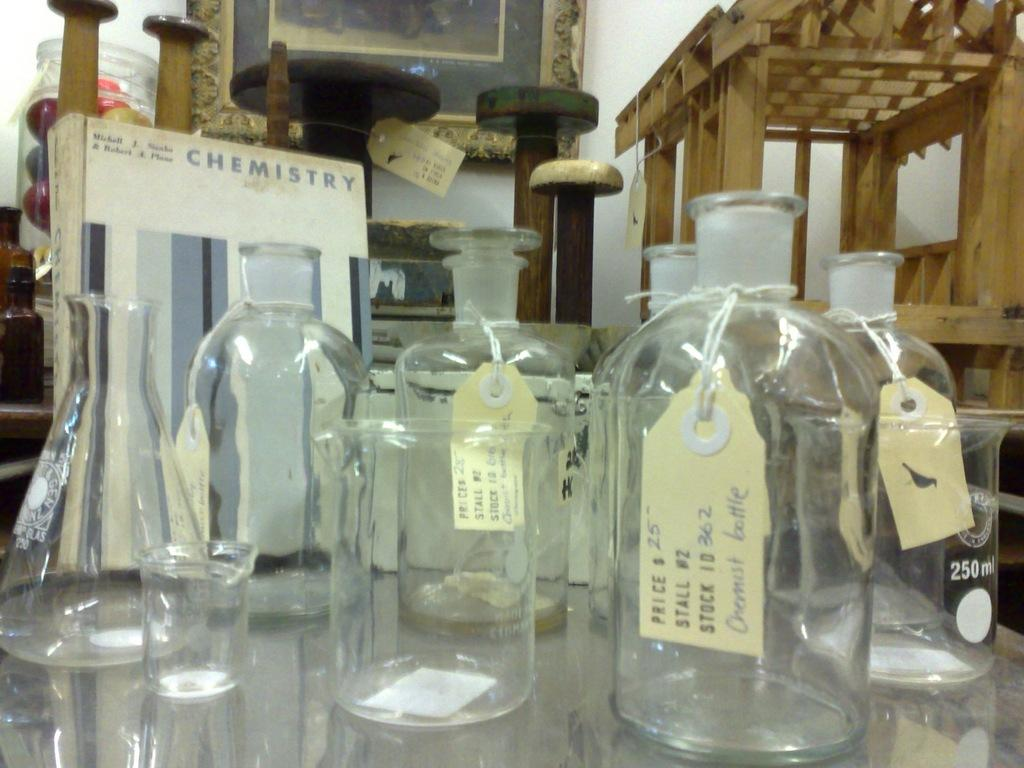What objects are on the table in the image? There are empty glass bottles on the table. What can be seen on the left side of the image? There is a board on the left side of the image. What is written on the board? The word "chemistry" is written on the board. How many girls are holding quivers in the image? There are no girls or quivers present in the image. 